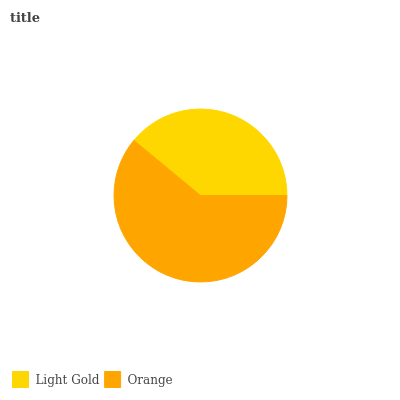Is Light Gold the minimum?
Answer yes or no. Yes. Is Orange the maximum?
Answer yes or no. Yes. Is Orange the minimum?
Answer yes or no. No. Is Orange greater than Light Gold?
Answer yes or no. Yes. Is Light Gold less than Orange?
Answer yes or no. Yes. Is Light Gold greater than Orange?
Answer yes or no. No. Is Orange less than Light Gold?
Answer yes or no. No. Is Orange the high median?
Answer yes or no. Yes. Is Light Gold the low median?
Answer yes or no. Yes. Is Light Gold the high median?
Answer yes or no. No. Is Orange the low median?
Answer yes or no. No. 